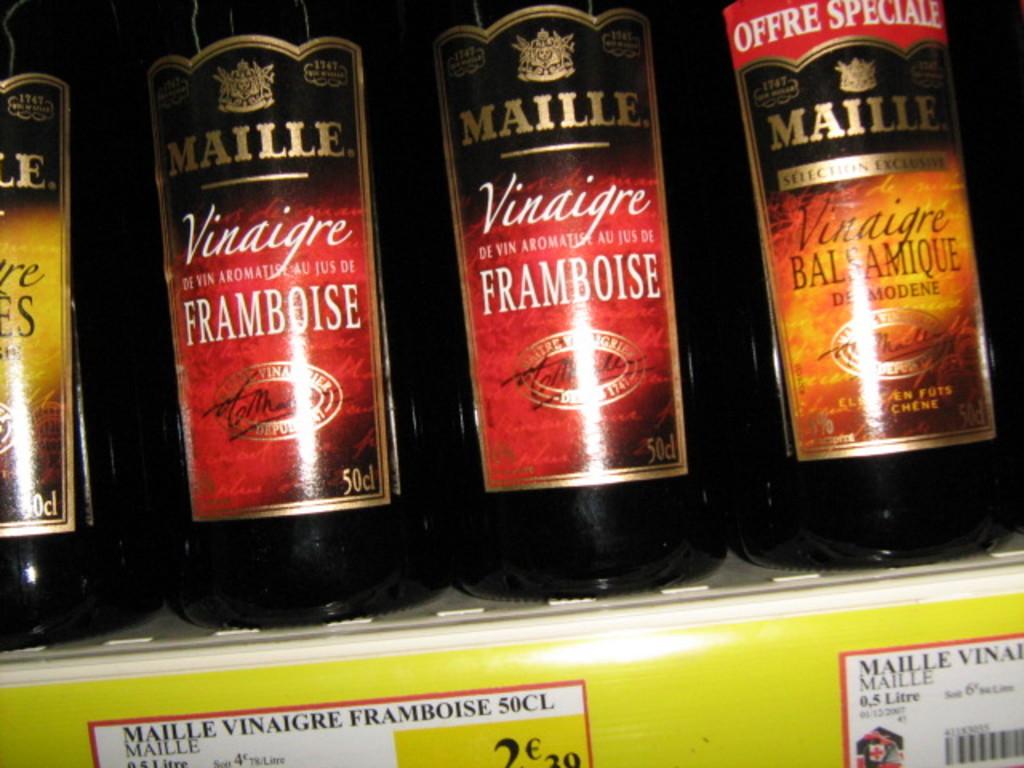What is the brand of these items?
Offer a terse response. Maille. What's the volume of the bottles?
Your response must be concise. 50cl. 